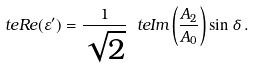Convert formula to latex. <formula><loc_0><loc_0><loc_500><loc_500>\ t e { R e } ( \varepsilon ^ { \prime } ) = \frac { 1 } { \sqrt { 2 } } \ t e { I m } \left ( \frac { A _ { 2 } } { A _ { 0 } } \right ) \sin \delta \, .</formula> 